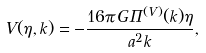Convert formula to latex. <formula><loc_0><loc_0><loc_500><loc_500>V ( \eta , k ) = - \frac { 1 6 \pi G \Pi ^ { ( V ) } ( k ) \eta } { a ^ { 2 } k } ,</formula> 